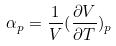<formula> <loc_0><loc_0><loc_500><loc_500>\alpha _ { p } = \frac { 1 } { V } ( \frac { \partial V } { \partial T } ) _ { p }</formula> 